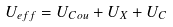Convert formula to latex. <formula><loc_0><loc_0><loc_500><loc_500>U _ { e f f } = U _ { C o u } + U _ { X } + U _ { C }</formula> 